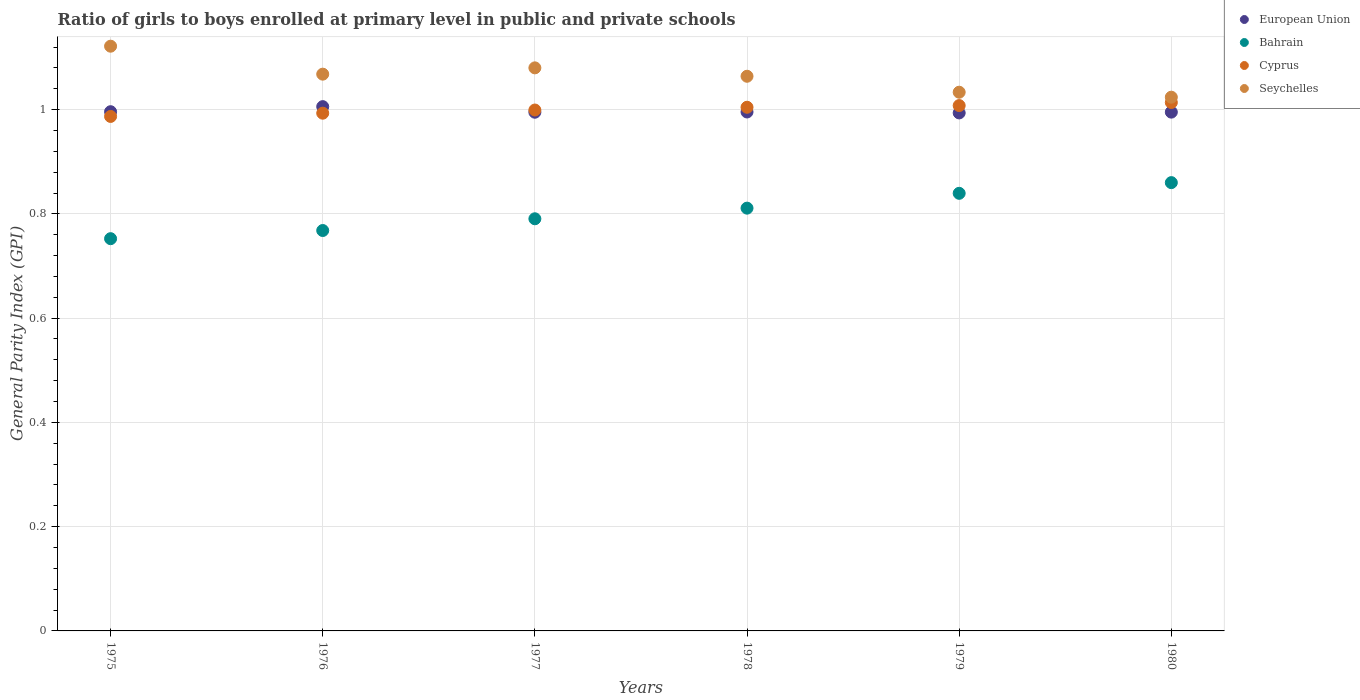Is the number of dotlines equal to the number of legend labels?
Provide a succinct answer. Yes. What is the general parity index in Seychelles in 1976?
Offer a terse response. 1.07. Across all years, what is the maximum general parity index in Bahrain?
Your answer should be compact. 0.86. Across all years, what is the minimum general parity index in Bahrain?
Provide a succinct answer. 0.75. In which year was the general parity index in European Union maximum?
Keep it short and to the point. 1976. In which year was the general parity index in European Union minimum?
Your response must be concise. 1979. What is the total general parity index in Seychelles in the graph?
Offer a very short reply. 6.39. What is the difference between the general parity index in Bahrain in 1975 and that in 1977?
Keep it short and to the point. -0.04. What is the difference between the general parity index in Bahrain in 1979 and the general parity index in Seychelles in 1976?
Offer a very short reply. -0.23. What is the average general parity index in Bahrain per year?
Make the answer very short. 0.8. In the year 1980, what is the difference between the general parity index in Bahrain and general parity index in Cyprus?
Provide a short and direct response. -0.15. In how many years, is the general parity index in European Union greater than 0.68?
Offer a terse response. 6. What is the ratio of the general parity index in Bahrain in 1977 to that in 1978?
Offer a very short reply. 0.97. Is the general parity index in Cyprus in 1978 less than that in 1979?
Provide a succinct answer. Yes. Is the difference between the general parity index in Bahrain in 1975 and 1977 greater than the difference between the general parity index in Cyprus in 1975 and 1977?
Make the answer very short. No. What is the difference between the highest and the second highest general parity index in Cyprus?
Give a very brief answer. 0.01. What is the difference between the highest and the lowest general parity index in Cyprus?
Your answer should be very brief. 0.03. Is it the case that in every year, the sum of the general parity index in Cyprus and general parity index in European Union  is greater than the sum of general parity index in Bahrain and general parity index in Seychelles?
Keep it short and to the point. No. Is the general parity index in Cyprus strictly greater than the general parity index in European Union over the years?
Provide a succinct answer. No. How many years are there in the graph?
Give a very brief answer. 6. What is the difference between two consecutive major ticks on the Y-axis?
Your answer should be very brief. 0.2. Are the values on the major ticks of Y-axis written in scientific E-notation?
Make the answer very short. No. How many legend labels are there?
Ensure brevity in your answer.  4. What is the title of the graph?
Provide a succinct answer. Ratio of girls to boys enrolled at primary level in public and private schools. What is the label or title of the X-axis?
Provide a succinct answer. Years. What is the label or title of the Y-axis?
Your answer should be very brief. General Parity Index (GPI). What is the General Parity Index (GPI) of European Union in 1975?
Keep it short and to the point. 1. What is the General Parity Index (GPI) of Bahrain in 1975?
Offer a terse response. 0.75. What is the General Parity Index (GPI) of Cyprus in 1975?
Your answer should be very brief. 0.99. What is the General Parity Index (GPI) in Seychelles in 1975?
Ensure brevity in your answer.  1.12. What is the General Parity Index (GPI) in European Union in 1976?
Your answer should be very brief. 1.01. What is the General Parity Index (GPI) in Bahrain in 1976?
Provide a short and direct response. 0.77. What is the General Parity Index (GPI) in Cyprus in 1976?
Offer a terse response. 0.99. What is the General Parity Index (GPI) of Seychelles in 1976?
Keep it short and to the point. 1.07. What is the General Parity Index (GPI) of European Union in 1977?
Ensure brevity in your answer.  0.99. What is the General Parity Index (GPI) of Bahrain in 1977?
Give a very brief answer. 0.79. What is the General Parity Index (GPI) in Cyprus in 1977?
Make the answer very short. 1. What is the General Parity Index (GPI) of Seychelles in 1977?
Your response must be concise. 1.08. What is the General Parity Index (GPI) in European Union in 1978?
Your answer should be compact. 1. What is the General Parity Index (GPI) in Bahrain in 1978?
Offer a very short reply. 0.81. What is the General Parity Index (GPI) in Cyprus in 1978?
Keep it short and to the point. 1. What is the General Parity Index (GPI) of Seychelles in 1978?
Provide a succinct answer. 1.06. What is the General Parity Index (GPI) in European Union in 1979?
Ensure brevity in your answer.  0.99. What is the General Parity Index (GPI) of Bahrain in 1979?
Give a very brief answer. 0.84. What is the General Parity Index (GPI) of Cyprus in 1979?
Give a very brief answer. 1.01. What is the General Parity Index (GPI) in Seychelles in 1979?
Provide a succinct answer. 1.03. What is the General Parity Index (GPI) in European Union in 1980?
Give a very brief answer. 1. What is the General Parity Index (GPI) in Bahrain in 1980?
Provide a succinct answer. 0.86. What is the General Parity Index (GPI) in Cyprus in 1980?
Offer a terse response. 1.01. What is the General Parity Index (GPI) of Seychelles in 1980?
Provide a succinct answer. 1.02. Across all years, what is the maximum General Parity Index (GPI) of European Union?
Ensure brevity in your answer.  1.01. Across all years, what is the maximum General Parity Index (GPI) of Bahrain?
Make the answer very short. 0.86. Across all years, what is the maximum General Parity Index (GPI) of Cyprus?
Make the answer very short. 1.01. Across all years, what is the maximum General Parity Index (GPI) of Seychelles?
Your response must be concise. 1.12. Across all years, what is the minimum General Parity Index (GPI) in European Union?
Provide a short and direct response. 0.99. Across all years, what is the minimum General Parity Index (GPI) of Bahrain?
Offer a terse response. 0.75. Across all years, what is the minimum General Parity Index (GPI) in Cyprus?
Offer a very short reply. 0.99. Across all years, what is the minimum General Parity Index (GPI) of Seychelles?
Make the answer very short. 1.02. What is the total General Parity Index (GPI) of European Union in the graph?
Provide a succinct answer. 5.98. What is the total General Parity Index (GPI) in Bahrain in the graph?
Your response must be concise. 4.82. What is the total General Parity Index (GPI) in Cyprus in the graph?
Offer a terse response. 6.01. What is the total General Parity Index (GPI) of Seychelles in the graph?
Your answer should be very brief. 6.39. What is the difference between the General Parity Index (GPI) of European Union in 1975 and that in 1976?
Keep it short and to the point. -0.01. What is the difference between the General Parity Index (GPI) in Bahrain in 1975 and that in 1976?
Offer a very short reply. -0.02. What is the difference between the General Parity Index (GPI) in Cyprus in 1975 and that in 1976?
Your answer should be compact. -0.01. What is the difference between the General Parity Index (GPI) of Seychelles in 1975 and that in 1976?
Provide a short and direct response. 0.05. What is the difference between the General Parity Index (GPI) of European Union in 1975 and that in 1977?
Your answer should be compact. 0. What is the difference between the General Parity Index (GPI) in Bahrain in 1975 and that in 1977?
Offer a terse response. -0.04. What is the difference between the General Parity Index (GPI) in Cyprus in 1975 and that in 1977?
Your answer should be compact. -0.01. What is the difference between the General Parity Index (GPI) in Seychelles in 1975 and that in 1977?
Offer a terse response. 0.04. What is the difference between the General Parity Index (GPI) of European Union in 1975 and that in 1978?
Your answer should be very brief. 0. What is the difference between the General Parity Index (GPI) in Bahrain in 1975 and that in 1978?
Make the answer very short. -0.06. What is the difference between the General Parity Index (GPI) in Cyprus in 1975 and that in 1978?
Offer a very short reply. -0.02. What is the difference between the General Parity Index (GPI) of Seychelles in 1975 and that in 1978?
Your answer should be very brief. 0.06. What is the difference between the General Parity Index (GPI) of European Union in 1975 and that in 1979?
Provide a short and direct response. 0. What is the difference between the General Parity Index (GPI) of Bahrain in 1975 and that in 1979?
Your answer should be compact. -0.09. What is the difference between the General Parity Index (GPI) of Cyprus in 1975 and that in 1979?
Your answer should be very brief. -0.02. What is the difference between the General Parity Index (GPI) of Seychelles in 1975 and that in 1979?
Keep it short and to the point. 0.09. What is the difference between the General Parity Index (GPI) in European Union in 1975 and that in 1980?
Your response must be concise. 0. What is the difference between the General Parity Index (GPI) in Bahrain in 1975 and that in 1980?
Provide a short and direct response. -0.11. What is the difference between the General Parity Index (GPI) in Cyprus in 1975 and that in 1980?
Keep it short and to the point. -0.03. What is the difference between the General Parity Index (GPI) of Seychelles in 1975 and that in 1980?
Offer a terse response. 0.1. What is the difference between the General Parity Index (GPI) of European Union in 1976 and that in 1977?
Offer a very short reply. 0.01. What is the difference between the General Parity Index (GPI) in Bahrain in 1976 and that in 1977?
Your answer should be compact. -0.02. What is the difference between the General Parity Index (GPI) of Cyprus in 1976 and that in 1977?
Offer a terse response. -0.01. What is the difference between the General Parity Index (GPI) in Seychelles in 1976 and that in 1977?
Your response must be concise. -0.01. What is the difference between the General Parity Index (GPI) in European Union in 1976 and that in 1978?
Give a very brief answer. 0.01. What is the difference between the General Parity Index (GPI) in Bahrain in 1976 and that in 1978?
Give a very brief answer. -0.04. What is the difference between the General Parity Index (GPI) in Cyprus in 1976 and that in 1978?
Your answer should be very brief. -0.01. What is the difference between the General Parity Index (GPI) in Seychelles in 1976 and that in 1978?
Your response must be concise. 0. What is the difference between the General Parity Index (GPI) in European Union in 1976 and that in 1979?
Give a very brief answer. 0.01. What is the difference between the General Parity Index (GPI) of Bahrain in 1976 and that in 1979?
Offer a very short reply. -0.07. What is the difference between the General Parity Index (GPI) in Cyprus in 1976 and that in 1979?
Offer a very short reply. -0.01. What is the difference between the General Parity Index (GPI) of Seychelles in 1976 and that in 1979?
Keep it short and to the point. 0.03. What is the difference between the General Parity Index (GPI) of European Union in 1976 and that in 1980?
Give a very brief answer. 0.01. What is the difference between the General Parity Index (GPI) of Bahrain in 1976 and that in 1980?
Your answer should be very brief. -0.09. What is the difference between the General Parity Index (GPI) in Cyprus in 1976 and that in 1980?
Provide a short and direct response. -0.02. What is the difference between the General Parity Index (GPI) of Seychelles in 1976 and that in 1980?
Offer a terse response. 0.04. What is the difference between the General Parity Index (GPI) of European Union in 1977 and that in 1978?
Your answer should be compact. -0. What is the difference between the General Parity Index (GPI) of Bahrain in 1977 and that in 1978?
Your response must be concise. -0.02. What is the difference between the General Parity Index (GPI) of Cyprus in 1977 and that in 1978?
Keep it short and to the point. -0.01. What is the difference between the General Parity Index (GPI) in Seychelles in 1977 and that in 1978?
Offer a terse response. 0.02. What is the difference between the General Parity Index (GPI) of European Union in 1977 and that in 1979?
Your answer should be compact. 0. What is the difference between the General Parity Index (GPI) of Bahrain in 1977 and that in 1979?
Your answer should be compact. -0.05. What is the difference between the General Parity Index (GPI) in Cyprus in 1977 and that in 1979?
Give a very brief answer. -0.01. What is the difference between the General Parity Index (GPI) in Seychelles in 1977 and that in 1979?
Offer a terse response. 0.05. What is the difference between the General Parity Index (GPI) of European Union in 1977 and that in 1980?
Ensure brevity in your answer.  -0. What is the difference between the General Parity Index (GPI) in Bahrain in 1977 and that in 1980?
Keep it short and to the point. -0.07. What is the difference between the General Parity Index (GPI) in Cyprus in 1977 and that in 1980?
Keep it short and to the point. -0.01. What is the difference between the General Parity Index (GPI) of Seychelles in 1977 and that in 1980?
Your answer should be compact. 0.06. What is the difference between the General Parity Index (GPI) of European Union in 1978 and that in 1979?
Your response must be concise. 0. What is the difference between the General Parity Index (GPI) of Bahrain in 1978 and that in 1979?
Provide a succinct answer. -0.03. What is the difference between the General Parity Index (GPI) in Cyprus in 1978 and that in 1979?
Offer a terse response. -0. What is the difference between the General Parity Index (GPI) in Seychelles in 1978 and that in 1979?
Your answer should be very brief. 0.03. What is the difference between the General Parity Index (GPI) of European Union in 1978 and that in 1980?
Give a very brief answer. 0. What is the difference between the General Parity Index (GPI) of Bahrain in 1978 and that in 1980?
Offer a very short reply. -0.05. What is the difference between the General Parity Index (GPI) in Cyprus in 1978 and that in 1980?
Your answer should be compact. -0.01. What is the difference between the General Parity Index (GPI) of Seychelles in 1978 and that in 1980?
Offer a terse response. 0.04. What is the difference between the General Parity Index (GPI) of European Union in 1979 and that in 1980?
Keep it short and to the point. -0. What is the difference between the General Parity Index (GPI) of Bahrain in 1979 and that in 1980?
Your answer should be very brief. -0.02. What is the difference between the General Parity Index (GPI) in Cyprus in 1979 and that in 1980?
Provide a succinct answer. -0.01. What is the difference between the General Parity Index (GPI) in Seychelles in 1979 and that in 1980?
Provide a short and direct response. 0.01. What is the difference between the General Parity Index (GPI) in European Union in 1975 and the General Parity Index (GPI) in Bahrain in 1976?
Make the answer very short. 0.23. What is the difference between the General Parity Index (GPI) of European Union in 1975 and the General Parity Index (GPI) of Cyprus in 1976?
Your answer should be very brief. 0. What is the difference between the General Parity Index (GPI) of European Union in 1975 and the General Parity Index (GPI) of Seychelles in 1976?
Keep it short and to the point. -0.07. What is the difference between the General Parity Index (GPI) of Bahrain in 1975 and the General Parity Index (GPI) of Cyprus in 1976?
Ensure brevity in your answer.  -0.24. What is the difference between the General Parity Index (GPI) of Bahrain in 1975 and the General Parity Index (GPI) of Seychelles in 1976?
Ensure brevity in your answer.  -0.32. What is the difference between the General Parity Index (GPI) in Cyprus in 1975 and the General Parity Index (GPI) in Seychelles in 1976?
Make the answer very short. -0.08. What is the difference between the General Parity Index (GPI) of European Union in 1975 and the General Parity Index (GPI) of Bahrain in 1977?
Offer a terse response. 0.21. What is the difference between the General Parity Index (GPI) of European Union in 1975 and the General Parity Index (GPI) of Cyprus in 1977?
Your answer should be compact. -0. What is the difference between the General Parity Index (GPI) of European Union in 1975 and the General Parity Index (GPI) of Seychelles in 1977?
Provide a short and direct response. -0.08. What is the difference between the General Parity Index (GPI) in Bahrain in 1975 and the General Parity Index (GPI) in Cyprus in 1977?
Your response must be concise. -0.25. What is the difference between the General Parity Index (GPI) in Bahrain in 1975 and the General Parity Index (GPI) in Seychelles in 1977?
Give a very brief answer. -0.33. What is the difference between the General Parity Index (GPI) in Cyprus in 1975 and the General Parity Index (GPI) in Seychelles in 1977?
Ensure brevity in your answer.  -0.09. What is the difference between the General Parity Index (GPI) in European Union in 1975 and the General Parity Index (GPI) in Bahrain in 1978?
Provide a short and direct response. 0.18. What is the difference between the General Parity Index (GPI) of European Union in 1975 and the General Parity Index (GPI) of Cyprus in 1978?
Provide a short and direct response. -0.01. What is the difference between the General Parity Index (GPI) in European Union in 1975 and the General Parity Index (GPI) in Seychelles in 1978?
Give a very brief answer. -0.07. What is the difference between the General Parity Index (GPI) of Bahrain in 1975 and the General Parity Index (GPI) of Cyprus in 1978?
Offer a very short reply. -0.25. What is the difference between the General Parity Index (GPI) in Bahrain in 1975 and the General Parity Index (GPI) in Seychelles in 1978?
Provide a succinct answer. -0.31. What is the difference between the General Parity Index (GPI) of Cyprus in 1975 and the General Parity Index (GPI) of Seychelles in 1978?
Offer a terse response. -0.08. What is the difference between the General Parity Index (GPI) in European Union in 1975 and the General Parity Index (GPI) in Bahrain in 1979?
Offer a very short reply. 0.16. What is the difference between the General Parity Index (GPI) of European Union in 1975 and the General Parity Index (GPI) of Cyprus in 1979?
Your response must be concise. -0.01. What is the difference between the General Parity Index (GPI) in European Union in 1975 and the General Parity Index (GPI) in Seychelles in 1979?
Your answer should be compact. -0.04. What is the difference between the General Parity Index (GPI) of Bahrain in 1975 and the General Parity Index (GPI) of Cyprus in 1979?
Keep it short and to the point. -0.26. What is the difference between the General Parity Index (GPI) in Bahrain in 1975 and the General Parity Index (GPI) in Seychelles in 1979?
Offer a very short reply. -0.28. What is the difference between the General Parity Index (GPI) of Cyprus in 1975 and the General Parity Index (GPI) of Seychelles in 1979?
Your answer should be compact. -0.05. What is the difference between the General Parity Index (GPI) in European Union in 1975 and the General Parity Index (GPI) in Bahrain in 1980?
Your answer should be very brief. 0.14. What is the difference between the General Parity Index (GPI) of European Union in 1975 and the General Parity Index (GPI) of Cyprus in 1980?
Provide a succinct answer. -0.02. What is the difference between the General Parity Index (GPI) of European Union in 1975 and the General Parity Index (GPI) of Seychelles in 1980?
Give a very brief answer. -0.03. What is the difference between the General Parity Index (GPI) of Bahrain in 1975 and the General Parity Index (GPI) of Cyprus in 1980?
Offer a very short reply. -0.26. What is the difference between the General Parity Index (GPI) in Bahrain in 1975 and the General Parity Index (GPI) in Seychelles in 1980?
Your answer should be very brief. -0.27. What is the difference between the General Parity Index (GPI) of Cyprus in 1975 and the General Parity Index (GPI) of Seychelles in 1980?
Your answer should be very brief. -0.04. What is the difference between the General Parity Index (GPI) in European Union in 1976 and the General Parity Index (GPI) in Bahrain in 1977?
Ensure brevity in your answer.  0.22. What is the difference between the General Parity Index (GPI) in European Union in 1976 and the General Parity Index (GPI) in Cyprus in 1977?
Your response must be concise. 0.01. What is the difference between the General Parity Index (GPI) of European Union in 1976 and the General Parity Index (GPI) of Seychelles in 1977?
Provide a short and direct response. -0.07. What is the difference between the General Parity Index (GPI) in Bahrain in 1976 and the General Parity Index (GPI) in Cyprus in 1977?
Ensure brevity in your answer.  -0.23. What is the difference between the General Parity Index (GPI) of Bahrain in 1976 and the General Parity Index (GPI) of Seychelles in 1977?
Your response must be concise. -0.31. What is the difference between the General Parity Index (GPI) in Cyprus in 1976 and the General Parity Index (GPI) in Seychelles in 1977?
Ensure brevity in your answer.  -0.09. What is the difference between the General Parity Index (GPI) in European Union in 1976 and the General Parity Index (GPI) in Bahrain in 1978?
Offer a very short reply. 0.19. What is the difference between the General Parity Index (GPI) of European Union in 1976 and the General Parity Index (GPI) of Cyprus in 1978?
Your response must be concise. 0. What is the difference between the General Parity Index (GPI) of European Union in 1976 and the General Parity Index (GPI) of Seychelles in 1978?
Provide a short and direct response. -0.06. What is the difference between the General Parity Index (GPI) of Bahrain in 1976 and the General Parity Index (GPI) of Cyprus in 1978?
Keep it short and to the point. -0.24. What is the difference between the General Parity Index (GPI) of Bahrain in 1976 and the General Parity Index (GPI) of Seychelles in 1978?
Your response must be concise. -0.3. What is the difference between the General Parity Index (GPI) of Cyprus in 1976 and the General Parity Index (GPI) of Seychelles in 1978?
Make the answer very short. -0.07. What is the difference between the General Parity Index (GPI) of European Union in 1976 and the General Parity Index (GPI) of Bahrain in 1979?
Offer a terse response. 0.17. What is the difference between the General Parity Index (GPI) of European Union in 1976 and the General Parity Index (GPI) of Cyprus in 1979?
Provide a short and direct response. -0. What is the difference between the General Parity Index (GPI) of European Union in 1976 and the General Parity Index (GPI) of Seychelles in 1979?
Your answer should be very brief. -0.03. What is the difference between the General Parity Index (GPI) of Bahrain in 1976 and the General Parity Index (GPI) of Cyprus in 1979?
Give a very brief answer. -0.24. What is the difference between the General Parity Index (GPI) of Bahrain in 1976 and the General Parity Index (GPI) of Seychelles in 1979?
Make the answer very short. -0.27. What is the difference between the General Parity Index (GPI) of Cyprus in 1976 and the General Parity Index (GPI) of Seychelles in 1979?
Offer a terse response. -0.04. What is the difference between the General Parity Index (GPI) in European Union in 1976 and the General Parity Index (GPI) in Bahrain in 1980?
Your answer should be very brief. 0.15. What is the difference between the General Parity Index (GPI) in European Union in 1976 and the General Parity Index (GPI) in Cyprus in 1980?
Your response must be concise. -0.01. What is the difference between the General Parity Index (GPI) of European Union in 1976 and the General Parity Index (GPI) of Seychelles in 1980?
Offer a terse response. -0.02. What is the difference between the General Parity Index (GPI) in Bahrain in 1976 and the General Parity Index (GPI) in Cyprus in 1980?
Provide a succinct answer. -0.25. What is the difference between the General Parity Index (GPI) of Bahrain in 1976 and the General Parity Index (GPI) of Seychelles in 1980?
Keep it short and to the point. -0.26. What is the difference between the General Parity Index (GPI) of Cyprus in 1976 and the General Parity Index (GPI) of Seychelles in 1980?
Offer a terse response. -0.03. What is the difference between the General Parity Index (GPI) of European Union in 1977 and the General Parity Index (GPI) of Bahrain in 1978?
Your answer should be compact. 0.18. What is the difference between the General Parity Index (GPI) of European Union in 1977 and the General Parity Index (GPI) of Cyprus in 1978?
Provide a short and direct response. -0.01. What is the difference between the General Parity Index (GPI) of European Union in 1977 and the General Parity Index (GPI) of Seychelles in 1978?
Keep it short and to the point. -0.07. What is the difference between the General Parity Index (GPI) in Bahrain in 1977 and the General Parity Index (GPI) in Cyprus in 1978?
Make the answer very short. -0.21. What is the difference between the General Parity Index (GPI) of Bahrain in 1977 and the General Parity Index (GPI) of Seychelles in 1978?
Keep it short and to the point. -0.27. What is the difference between the General Parity Index (GPI) in Cyprus in 1977 and the General Parity Index (GPI) in Seychelles in 1978?
Keep it short and to the point. -0.06. What is the difference between the General Parity Index (GPI) of European Union in 1977 and the General Parity Index (GPI) of Bahrain in 1979?
Provide a succinct answer. 0.16. What is the difference between the General Parity Index (GPI) of European Union in 1977 and the General Parity Index (GPI) of Cyprus in 1979?
Your response must be concise. -0.01. What is the difference between the General Parity Index (GPI) in European Union in 1977 and the General Parity Index (GPI) in Seychelles in 1979?
Your response must be concise. -0.04. What is the difference between the General Parity Index (GPI) of Bahrain in 1977 and the General Parity Index (GPI) of Cyprus in 1979?
Provide a short and direct response. -0.22. What is the difference between the General Parity Index (GPI) in Bahrain in 1977 and the General Parity Index (GPI) in Seychelles in 1979?
Your response must be concise. -0.24. What is the difference between the General Parity Index (GPI) in Cyprus in 1977 and the General Parity Index (GPI) in Seychelles in 1979?
Provide a succinct answer. -0.03. What is the difference between the General Parity Index (GPI) in European Union in 1977 and the General Parity Index (GPI) in Bahrain in 1980?
Ensure brevity in your answer.  0.14. What is the difference between the General Parity Index (GPI) in European Union in 1977 and the General Parity Index (GPI) in Cyprus in 1980?
Keep it short and to the point. -0.02. What is the difference between the General Parity Index (GPI) of European Union in 1977 and the General Parity Index (GPI) of Seychelles in 1980?
Your answer should be very brief. -0.03. What is the difference between the General Parity Index (GPI) of Bahrain in 1977 and the General Parity Index (GPI) of Cyprus in 1980?
Your answer should be compact. -0.22. What is the difference between the General Parity Index (GPI) of Bahrain in 1977 and the General Parity Index (GPI) of Seychelles in 1980?
Provide a succinct answer. -0.23. What is the difference between the General Parity Index (GPI) in Cyprus in 1977 and the General Parity Index (GPI) in Seychelles in 1980?
Your answer should be compact. -0.02. What is the difference between the General Parity Index (GPI) of European Union in 1978 and the General Parity Index (GPI) of Bahrain in 1979?
Your response must be concise. 0.16. What is the difference between the General Parity Index (GPI) of European Union in 1978 and the General Parity Index (GPI) of Cyprus in 1979?
Ensure brevity in your answer.  -0.01. What is the difference between the General Parity Index (GPI) of European Union in 1978 and the General Parity Index (GPI) of Seychelles in 1979?
Your answer should be compact. -0.04. What is the difference between the General Parity Index (GPI) in Bahrain in 1978 and the General Parity Index (GPI) in Cyprus in 1979?
Your answer should be very brief. -0.2. What is the difference between the General Parity Index (GPI) in Bahrain in 1978 and the General Parity Index (GPI) in Seychelles in 1979?
Provide a short and direct response. -0.22. What is the difference between the General Parity Index (GPI) of Cyprus in 1978 and the General Parity Index (GPI) of Seychelles in 1979?
Your answer should be compact. -0.03. What is the difference between the General Parity Index (GPI) in European Union in 1978 and the General Parity Index (GPI) in Bahrain in 1980?
Give a very brief answer. 0.14. What is the difference between the General Parity Index (GPI) of European Union in 1978 and the General Parity Index (GPI) of Cyprus in 1980?
Give a very brief answer. -0.02. What is the difference between the General Parity Index (GPI) in European Union in 1978 and the General Parity Index (GPI) in Seychelles in 1980?
Your answer should be very brief. -0.03. What is the difference between the General Parity Index (GPI) in Bahrain in 1978 and the General Parity Index (GPI) in Cyprus in 1980?
Offer a terse response. -0.2. What is the difference between the General Parity Index (GPI) of Bahrain in 1978 and the General Parity Index (GPI) of Seychelles in 1980?
Offer a very short reply. -0.21. What is the difference between the General Parity Index (GPI) of Cyprus in 1978 and the General Parity Index (GPI) of Seychelles in 1980?
Make the answer very short. -0.02. What is the difference between the General Parity Index (GPI) of European Union in 1979 and the General Parity Index (GPI) of Bahrain in 1980?
Give a very brief answer. 0.13. What is the difference between the General Parity Index (GPI) in European Union in 1979 and the General Parity Index (GPI) in Cyprus in 1980?
Your answer should be compact. -0.02. What is the difference between the General Parity Index (GPI) of European Union in 1979 and the General Parity Index (GPI) of Seychelles in 1980?
Provide a short and direct response. -0.03. What is the difference between the General Parity Index (GPI) in Bahrain in 1979 and the General Parity Index (GPI) in Cyprus in 1980?
Offer a very short reply. -0.17. What is the difference between the General Parity Index (GPI) of Bahrain in 1979 and the General Parity Index (GPI) of Seychelles in 1980?
Your response must be concise. -0.18. What is the difference between the General Parity Index (GPI) of Cyprus in 1979 and the General Parity Index (GPI) of Seychelles in 1980?
Ensure brevity in your answer.  -0.02. What is the average General Parity Index (GPI) of European Union per year?
Offer a terse response. 1. What is the average General Parity Index (GPI) in Bahrain per year?
Your response must be concise. 0.8. What is the average General Parity Index (GPI) of Cyprus per year?
Offer a very short reply. 1. What is the average General Parity Index (GPI) in Seychelles per year?
Provide a succinct answer. 1.07. In the year 1975, what is the difference between the General Parity Index (GPI) in European Union and General Parity Index (GPI) in Bahrain?
Your answer should be compact. 0.24. In the year 1975, what is the difference between the General Parity Index (GPI) in European Union and General Parity Index (GPI) in Cyprus?
Offer a terse response. 0.01. In the year 1975, what is the difference between the General Parity Index (GPI) of European Union and General Parity Index (GPI) of Seychelles?
Offer a very short reply. -0.13. In the year 1975, what is the difference between the General Parity Index (GPI) in Bahrain and General Parity Index (GPI) in Cyprus?
Keep it short and to the point. -0.23. In the year 1975, what is the difference between the General Parity Index (GPI) in Bahrain and General Parity Index (GPI) in Seychelles?
Keep it short and to the point. -0.37. In the year 1975, what is the difference between the General Parity Index (GPI) in Cyprus and General Parity Index (GPI) in Seychelles?
Your answer should be very brief. -0.13. In the year 1976, what is the difference between the General Parity Index (GPI) of European Union and General Parity Index (GPI) of Bahrain?
Provide a short and direct response. 0.24. In the year 1976, what is the difference between the General Parity Index (GPI) of European Union and General Parity Index (GPI) of Cyprus?
Ensure brevity in your answer.  0.01. In the year 1976, what is the difference between the General Parity Index (GPI) in European Union and General Parity Index (GPI) in Seychelles?
Offer a very short reply. -0.06. In the year 1976, what is the difference between the General Parity Index (GPI) of Bahrain and General Parity Index (GPI) of Cyprus?
Your answer should be very brief. -0.23. In the year 1976, what is the difference between the General Parity Index (GPI) of Bahrain and General Parity Index (GPI) of Seychelles?
Provide a succinct answer. -0.3. In the year 1976, what is the difference between the General Parity Index (GPI) in Cyprus and General Parity Index (GPI) in Seychelles?
Ensure brevity in your answer.  -0.07. In the year 1977, what is the difference between the General Parity Index (GPI) in European Union and General Parity Index (GPI) in Bahrain?
Give a very brief answer. 0.2. In the year 1977, what is the difference between the General Parity Index (GPI) in European Union and General Parity Index (GPI) in Cyprus?
Your answer should be compact. -0. In the year 1977, what is the difference between the General Parity Index (GPI) of European Union and General Parity Index (GPI) of Seychelles?
Give a very brief answer. -0.09. In the year 1977, what is the difference between the General Parity Index (GPI) of Bahrain and General Parity Index (GPI) of Cyprus?
Keep it short and to the point. -0.21. In the year 1977, what is the difference between the General Parity Index (GPI) of Bahrain and General Parity Index (GPI) of Seychelles?
Provide a succinct answer. -0.29. In the year 1977, what is the difference between the General Parity Index (GPI) in Cyprus and General Parity Index (GPI) in Seychelles?
Your answer should be compact. -0.08. In the year 1978, what is the difference between the General Parity Index (GPI) of European Union and General Parity Index (GPI) of Bahrain?
Your answer should be compact. 0.18. In the year 1978, what is the difference between the General Parity Index (GPI) in European Union and General Parity Index (GPI) in Cyprus?
Give a very brief answer. -0.01. In the year 1978, what is the difference between the General Parity Index (GPI) of European Union and General Parity Index (GPI) of Seychelles?
Make the answer very short. -0.07. In the year 1978, what is the difference between the General Parity Index (GPI) in Bahrain and General Parity Index (GPI) in Cyprus?
Your response must be concise. -0.19. In the year 1978, what is the difference between the General Parity Index (GPI) of Bahrain and General Parity Index (GPI) of Seychelles?
Provide a succinct answer. -0.25. In the year 1978, what is the difference between the General Parity Index (GPI) of Cyprus and General Parity Index (GPI) of Seychelles?
Provide a succinct answer. -0.06. In the year 1979, what is the difference between the General Parity Index (GPI) in European Union and General Parity Index (GPI) in Bahrain?
Your answer should be very brief. 0.15. In the year 1979, what is the difference between the General Parity Index (GPI) in European Union and General Parity Index (GPI) in Cyprus?
Offer a very short reply. -0.01. In the year 1979, what is the difference between the General Parity Index (GPI) of European Union and General Parity Index (GPI) of Seychelles?
Offer a terse response. -0.04. In the year 1979, what is the difference between the General Parity Index (GPI) of Bahrain and General Parity Index (GPI) of Cyprus?
Make the answer very short. -0.17. In the year 1979, what is the difference between the General Parity Index (GPI) in Bahrain and General Parity Index (GPI) in Seychelles?
Offer a very short reply. -0.19. In the year 1979, what is the difference between the General Parity Index (GPI) in Cyprus and General Parity Index (GPI) in Seychelles?
Provide a short and direct response. -0.03. In the year 1980, what is the difference between the General Parity Index (GPI) in European Union and General Parity Index (GPI) in Bahrain?
Ensure brevity in your answer.  0.14. In the year 1980, what is the difference between the General Parity Index (GPI) of European Union and General Parity Index (GPI) of Cyprus?
Keep it short and to the point. -0.02. In the year 1980, what is the difference between the General Parity Index (GPI) in European Union and General Parity Index (GPI) in Seychelles?
Provide a short and direct response. -0.03. In the year 1980, what is the difference between the General Parity Index (GPI) of Bahrain and General Parity Index (GPI) of Cyprus?
Make the answer very short. -0.15. In the year 1980, what is the difference between the General Parity Index (GPI) of Bahrain and General Parity Index (GPI) of Seychelles?
Provide a short and direct response. -0.16. In the year 1980, what is the difference between the General Parity Index (GPI) of Cyprus and General Parity Index (GPI) of Seychelles?
Provide a short and direct response. -0.01. What is the ratio of the General Parity Index (GPI) in European Union in 1975 to that in 1976?
Provide a short and direct response. 0.99. What is the ratio of the General Parity Index (GPI) in Bahrain in 1975 to that in 1976?
Provide a succinct answer. 0.98. What is the ratio of the General Parity Index (GPI) in Seychelles in 1975 to that in 1976?
Your answer should be very brief. 1.05. What is the ratio of the General Parity Index (GPI) of European Union in 1975 to that in 1977?
Provide a short and direct response. 1. What is the ratio of the General Parity Index (GPI) in Bahrain in 1975 to that in 1977?
Provide a succinct answer. 0.95. What is the ratio of the General Parity Index (GPI) in Cyprus in 1975 to that in 1977?
Provide a short and direct response. 0.99. What is the ratio of the General Parity Index (GPI) of Seychelles in 1975 to that in 1977?
Provide a succinct answer. 1.04. What is the ratio of the General Parity Index (GPI) of European Union in 1975 to that in 1978?
Keep it short and to the point. 1. What is the ratio of the General Parity Index (GPI) in Bahrain in 1975 to that in 1978?
Ensure brevity in your answer.  0.93. What is the ratio of the General Parity Index (GPI) of Cyprus in 1975 to that in 1978?
Give a very brief answer. 0.98. What is the ratio of the General Parity Index (GPI) in Seychelles in 1975 to that in 1978?
Provide a short and direct response. 1.05. What is the ratio of the General Parity Index (GPI) of Bahrain in 1975 to that in 1979?
Give a very brief answer. 0.9. What is the ratio of the General Parity Index (GPI) of Cyprus in 1975 to that in 1979?
Provide a short and direct response. 0.98. What is the ratio of the General Parity Index (GPI) of Seychelles in 1975 to that in 1979?
Ensure brevity in your answer.  1.09. What is the ratio of the General Parity Index (GPI) of Cyprus in 1975 to that in 1980?
Your answer should be compact. 0.97. What is the ratio of the General Parity Index (GPI) of Seychelles in 1975 to that in 1980?
Provide a short and direct response. 1.1. What is the ratio of the General Parity Index (GPI) of European Union in 1976 to that in 1977?
Your response must be concise. 1.01. What is the ratio of the General Parity Index (GPI) in Bahrain in 1976 to that in 1977?
Your response must be concise. 0.97. What is the ratio of the General Parity Index (GPI) in Cyprus in 1976 to that in 1977?
Give a very brief answer. 0.99. What is the ratio of the General Parity Index (GPI) in Seychelles in 1976 to that in 1977?
Give a very brief answer. 0.99. What is the ratio of the General Parity Index (GPI) of European Union in 1976 to that in 1978?
Offer a very short reply. 1.01. What is the ratio of the General Parity Index (GPI) of Bahrain in 1976 to that in 1978?
Your answer should be very brief. 0.95. What is the ratio of the General Parity Index (GPI) in Cyprus in 1976 to that in 1978?
Offer a terse response. 0.99. What is the ratio of the General Parity Index (GPI) in European Union in 1976 to that in 1979?
Your answer should be very brief. 1.01. What is the ratio of the General Parity Index (GPI) in Bahrain in 1976 to that in 1979?
Offer a very short reply. 0.92. What is the ratio of the General Parity Index (GPI) in Cyprus in 1976 to that in 1979?
Ensure brevity in your answer.  0.99. What is the ratio of the General Parity Index (GPI) of Seychelles in 1976 to that in 1979?
Provide a succinct answer. 1.03. What is the ratio of the General Parity Index (GPI) of European Union in 1976 to that in 1980?
Offer a terse response. 1.01. What is the ratio of the General Parity Index (GPI) in Bahrain in 1976 to that in 1980?
Make the answer very short. 0.89. What is the ratio of the General Parity Index (GPI) of Cyprus in 1976 to that in 1980?
Keep it short and to the point. 0.98. What is the ratio of the General Parity Index (GPI) in Seychelles in 1976 to that in 1980?
Provide a succinct answer. 1.04. What is the ratio of the General Parity Index (GPI) of Bahrain in 1977 to that in 1978?
Give a very brief answer. 0.97. What is the ratio of the General Parity Index (GPI) in Seychelles in 1977 to that in 1978?
Offer a terse response. 1.02. What is the ratio of the General Parity Index (GPI) of Bahrain in 1977 to that in 1979?
Your answer should be very brief. 0.94. What is the ratio of the General Parity Index (GPI) in Cyprus in 1977 to that in 1979?
Keep it short and to the point. 0.99. What is the ratio of the General Parity Index (GPI) of Seychelles in 1977 to that in 1979?
Provide a short and direct response. 1.05. What is the ratio of the General Parity Index (GPI) in European Union in 1977 to that in 1980?
Offer a very short reply. 1. What is the ratio of the General Parity Index (GPI) in Bahrain in 1977 to that in 1980?
Offer a very short reply. 0.92. What is the ratio of the General Parity Index (GPI) in Cyprus in 1977 to that in 1980?
Offer a terse response. 0.99. What is the ratio of the General Parity Index (GPI) in Seychelles in 1977 to that in 1980?
Provide a succinct answer. 1.05. What is the ratio of the General Parity Index (GPI) in European Union in 1978 to that in 1979?
Offer a terse response. 1. What is the ratio of the General Parity Index (GPI) of Bahrain in 1978 to that in 1979?
Offer a terse response. 0.97. What is the ratio of the General Parity Index (GPI) of Cyprus in 1978 to that in 1979?
Provide a short and direct response. 1. What is the ratio of the General Parity Index (GPI) in Seychelles in 1978 to that in 1979?
Your answer should be compact. 1.03. What is the ratio of the General Parity Index (GPI) in European Union in 1978 to that in 1980?
Provide a succinct answer. 1. What is the ratio of the General Parity Index (GPI) of Bahrain in 1978 to that in 1980?
Give a very brief answer. 0.94. What is the ratio of the General Parity Index (GPI) of Cyprus in 1978 to that in 1980?
Your response must be concise. 0.99. What is the ratio of the General Parity Index (GPI) in Seychelles in 1978 to that in 1980?
Your response must be concise. 1.04. What is the ratio of the General Parity Index (GPI) of European Union in 1979 to that in 1980?
Your answer should be compact. 1. What is the ratio of the General Parity Index (GPI) in Bahrain in 1979 to that in 1980?
Provide a succinct answer. 0.98. What is the ratio of the General Parity Index (GPI) of Seychelles in 1979 to that in 1980?
Keep it short and to the point. 1.01. What is the difference between the highest and the second highest General Parity Index (GPI) in European Union?
Provide a succinct answer. 0.01. What is the difference between the highest and the second highest General Parity Index (GPI) of Bahrain?
Your answer should be compact. 0.02. What is the difference between the highest and the second highest General Parity Index (GPI) in Cyprus?
Offer a very short reply. 0.01. What is the difference between the highest and the second highest General Parity Index (GPI) of Seychelles?
Offer a very short reply. 0.04. What is the difference between the highest and the lowest General Parity Index (GPI) in European Union?
Offer a terse response. 0.01. What is the difference between the highest and the lowest General Parity Index (GPI) of Bahrain?
Your answer should be very brief. 0.11. What is the difference between the highest and the lowest General Parity Index (GPI) in Cyprus?
Your response must be concise. 0.03. What is the difference between the highest and the lowest General Parity Index (GPI) of Seychelles?
Provide a short and direct response. 0.1. 